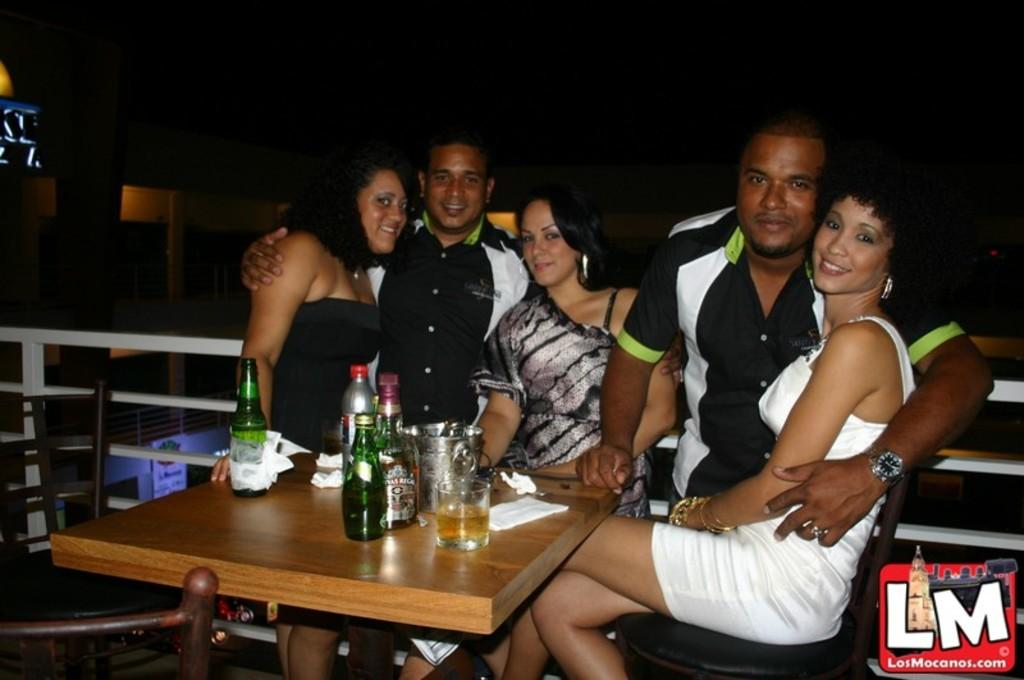How many people are in the image? There are five persons in the image. What is the facial expression of the people in the image? All the persons are smiling. What is located in the center of the image? There is a table in the image. What items can be seen on the table? A wine bottle, a glass, and tissues are on the table. Where are the chairs located in the image? The chairs are on the left side of the image. What type of insurance policy is being discussed by the persons in the image? There is no indication in the image that the persons are discussing any insurance policies. Can you tell me what the chance of rain is in the image? The image does not provide any information about the weather or the chance of rain. 